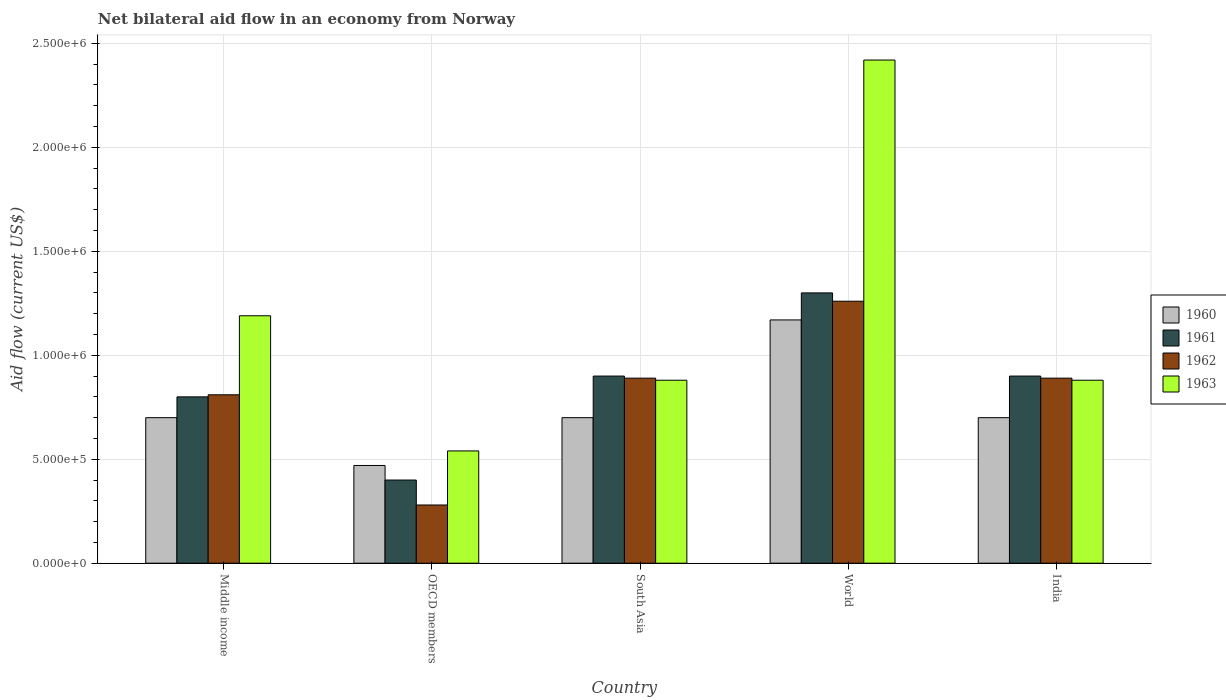How many groups of bars are there?
Offer a very short reply. 5. Are the number of bars per tick equal to the number of legend labels?
Ensure brevity in your answer.  Yes. Are the number of bars on each tick of the X-axis equal?
Your answer should be very brief. Yes. How many bars are there on the 2nd tick from the left?
Give a very brief answer. 4. What is the net bilateral aid flow in 1960 in World?
Make the answer very short. 1.17e+06. Across all countries, what is the maximum net bilateral aid flow in 1961?
Provide a short and direct response. 1.30e+06. What is the total net bilateral aid flow in 1961 in the graph?
Provide a short and direct response. 4.30e+06. What is the difference between the net bilateral aid flow in 1960 in South Asia and that in World?
Give a very brief answer. -4.70e+05. What is the difference between the net bilateral aid flow in 1960 in India and the net bilateral aid flow in 1962 in World?
Keep it short and to the point. -5.60e+05. What is the average net bilateral aid flow in 1963 per country?
Ensure brevity in your answer.  1.18e+06. In how many countries, is the net bilateral aid flow in 1960 greater than 1700000 US$?
Give a very brief answer. 0. What is the ratio of the net bilateral aid flow in 1963 in OECD members to that in South Asia?
Offer a terse response. 0.61. Is the net bilateral aid flow in 1963 in India less than that in OECD members?
Offer a very short reply. No. Is the difference between the net bilateral aid flow in 1960 in Middle income and OECD members greater than the difference between the net bilateral aid flow in 1963 in Middle income and OECD members?
Keep it short and to the point. No. What is the difference between the highest and the second highest net bilateral aid flow in 1961?
Offer a terse response. 4.00e+05. What is the difference between the highest and the lowest net bilateral aid flow in 1963?
Ensure brevity in your answer.  1.88e+06. In how many countries, is the net bilateral aid flow in 1963 greater than the average net bilateral aid flow in 1963 taken over all countries?
Your answer should be very brief. 2. Is it the case that in every country, the sum of the net bilateral aid flow in 1961 and net bilateral aid flow in 1962 is greater than the sum of net bilateral aid flow in 1960 and net bilateral aid flow in 1963?
Make the answer very short. No. Is it the case that in every country, the sum of the net bilateral aid flow in 1960 and net bilateral aid flow in 1961 is greater than the net bilateral aid flow in 1963?
Your response must be concise. Yes. Are the values on the major ticks of Y-axis written in scientific E-notation?
Provide a succinct answer. Yes. Does the graph contain any zero values?
Give a very brief answer. No. How many legend labels are there?
Offer a very short reply. 4. What is the title of the graph?
Offer a terse response. Net bilateral aid flow in an economy from Norway. Does "1974" appear as one of the legend labels in the graph?
Ensure brevity in your answer.  No. What is the Aid flow (current US$) of 1960 in Middle income?
Offer a very short reply. 7.00e+05. What is the Aid flow (current US$) in 1961 in Middle income?
Provide a short and direct response. 8.00e+05. What is the Aid flow (current US$) of 1962 in Middle income?
Make the answer very short. 8.10e+05. What is the Aid flow (current US$) in 1963 in Middle income?
Your answer should be very brief. 1.19e+06. What is the Aid flow (current US$) of 1963 in OECD members?
Ensure brevity in your answer.  5.40e+05. What is the Aid flow (current US$) of 1960 in South Asia?
Give a very brief answer. 7.00e+05. What is the Aid flow (current US$) in 1962 in South Asia?
Provide a short and direct response. 8.90e+05. What is the Aid flow (current US$) of 1963 in South Asia?
Offer a very short reply. 8.80e+05. What is the Aid flow (current US$) of 1960 in World?
Offer a terse response. 1.17e+06. What is the Aid flow (current US$) in 1961 in World?
Provide a short and direct response. 1.30e+06. What is the Aid flow (current US$) of 1962 in World?
Ensure brevity in your answer.  1.26e+06. What is the Aid flow (current US$) of 1963 in World?
Keep it short and to the point. 2.42e+06. What is the Aid flow (current US$) in 1961 in India?
Offer a terse response. 9.00e+05. What is the Aid flow (current US$) of 1962 in India?
Your answer should be very brief. 8.90e+05. What is the Aid flow (current US$) of 1963 in India?
Offer a very short reply. 8.80e+05. Across all countries, what is the maximum Aid flow (current US$) in 1960?
Your response must be concise. 1.17e+06. Across all countries, what is the maximum Aid flow (current US$) of 1961?
Offer a very short reply. 1.30e+06. Across all countries, what is the maximum Aid flow (current US$) in 1962?
Provide a succinct answer. 1.26e+06. Across all countries, what is the maximum Aid flow (current US$) of 1963?
Your response must be concise. 2.42e+06. Across all countries, what is the minimum Aid flow (current US$) in 1963?
Your response must be concise. 5.40e+05. What is the total Aid flow (current US$) in 1960 in the graph?
Your answer should be very brief. 3.74e+06. What is the total Aid flow (current US$) of 1961 in the graph?
Give a very brief answer. 4.30e+06. What is the total Aid flow (current US$) in 1962 in the graph?
Your answer should be very brief. 4.13e+06. What is the total Aid flow (current US$) of 1963 in the graph?
Your answer should be very brief. 5.91e+06. What is the difference between the Aid flow (current US$) in 1960 in Middle income and that in OECD members?
Offer a terse response. 2.30e+05. What is the difference between the Aid flow (current US$) of 1962 in Middle income and that in OECD members?
Ensure brevity in your answer.  5.30e+05. What is the difference between the Aid flow (current US$) of 1963 in Middle income and that in OECD members?
Give a very brief answer. 6.50e+05. What is the difference between the Aid flow (current US$) of 1960 in Middle income and that in South Asia?
Provide a short and direct response. 0. What is the difference between the Aid flow (current US$) in 1962 in Middle income and that in South Asia?
Provide a short and direct response. -8.00e+04. What is the difference between the Aid flow (current US$) in 1960 in Middle income and that in World?
Your response must be concise. -4.70e+05. What is the difference between the Aid flow (current US$) of 1961 in Middle income and that in World?
Provide a short and direct response. -5.00e+05. What is the difference between the Aid flow (current US$) in 1962 in Middle income and that in World?
Provide a short and direct response. -4.50e+05. What is the difference between the Aid flow (current US$) in 1963 in Middle income and that in World?
Your answer should be compact. -1.23e+06. What is the difference between the Aid flow (current US$) in 1960 in OECD members and that in South Asia?
Provide a short and direct response. -2.30e+05. What is the difference between the Aid flow (current US$) of 1961 in OECD members and that in South Asia?
Your answer should be very brief. -5.00e+05. What is the difference between the Aid flow (current US$) in 1962 in OECD members and that in South Asia?
Your answer should be compact. -6.10e+05. What is the difference between the Aid flow (current US$) of 1960 in OECD members and that in World?
Provide a short and direct response. -7.00e+05. What is the difference between the Aid flow (current US$) of 1961 in OECD members and that in World?
Provide a succinct answer. -9.00e+05. What is the difference between the Aid flow (current US$) in 1962 in OECD members and that in World?
Offer a very short reply. -9.80e+05. What is the difference between the Aid flow (current US$) in 1963 in OECD members and that in World?
Make the answer very short. -1.88e+06. What is the difference between the Aid flow (current US$) of 1960 in OECD members and that in India?
Make the answer very short. -2.30e+05. What is the difference between the Aid flow (current US$) in 1961 in OECD members and that in India?
Offer a terse response. -5.00e+05. What is the difference between the Aid flow (current US$) in 1962 in OECD members and that in India?
Keep it short and to the point. -6.10e+05. What is the difference between the Aid flow (current US$) of 1963 in OECD members and that in India?
Keep it short and to the point. -3.40e+05. What is the difference between the Aid flow (current US$) in 1960 in South Asia and that in World?
Make the answer very short. -4.70e+05. What is the difference between the Aid flow (current US$) of 1961 in South Asia and that in World?
Provide a short and direct response. -4.00e+05. What is the difference between the Aid flow (current US$) in 1962 in South Asia and that in World?
Make the answer very short. -3.70e+05. What is the difference between the Aid flow (current US$) of 1963 in South Asia and that in World?
Provide a succinct answer. -1.54e+06. What is the difference between the Aid flow (current US$) in 1960 in South Asia and that in India?
Provide a short and direct response. 0. What is the difference between the Aid flow (current US$) of 1960 in World and that in India?
Make the answer very short. 4.70e+05. What is the difference between the Aid flow (current US$) of 1963 in World and that in India?
Offer a terse response. 1.54e+06. What is the difference between the Aid flow (current US$) of 1960 in Middle income and the Aid flow (current US$) of 1962 in OECD members?
Your answer should be compact. 4.20e+05. What is the difference between the Aid flow (current US$) in 1960 in Middle income and the Aid flow (current US$) in 1963 in OECD members?
Offer a very short reply. 1.60e+05. What is the difference between the Aid flow (current US$) in 1961 in Middle income and the Aid flow (current US$) in 1962 in OECD members?
Ensure brevity in your answer.  5.20e+05. What is the difference between the Aid flow (current US$) of 1961 in Middle income and the Aid flow (current US$) of 1963 in OECD members?
Offer a very short reply. 2.60e+05. What is the difference between the Aid flow (current US$) of 1962 in Middle income and the Aid flow (current US$) of 1963 in OECD members?
Your answer should be very brief. 2.70e+05. What is the difference between the Aid flow (current US$) of 1960 in Middle income and the Aid flow (current US$) of 1961 in South Asia?
Offer a very short reply. -2.00e+05. What is the difference between the Aid flow (current US$) in 1960 in Middle income and the Aid flow (current US$) in 1962 in South Asia?
Your answer should be very brief. -1.90e+05. What is the difference between the Aid flow (current US$) of 1961 in Middle income and the Aid flow (current US$) of 1962 in South Asia?
Your answer should be compact. -9.00e+04. What is the difference between the Aid flow (current US$) in 1961 in Middle income and the Aid flow (current US$) in 1963 in South Asia?
Your answer should be compact. -8.00e+04. What is the difference between the Aid flow (current US$) in 1960 in Middle income and the Aid flow (current US$) in 1961 in World?
Offer a terse response. -6.00e+05. What is the difference between the Aid flow (current US$) in 1960 in Middle income and the Aid flow (current US$) in 1962 in World?
Provide a short and direct response. -5.60e+05. What is the difference between the Aid flow (current US$) in 1960 in Middle income and the Aid flow (current US$) in 1963 in World?
Offer a very short reply. -1.72e+06. What is the difference between the Aid flow (current US$) in 1961 in Middle income and the Aid flow (current US$) in 1962 in World?
Make the answer very short. -4.60e+05. What is the difference between the Aid flow (current US$) of 1961 in Middle income and the Aid flow (current US$) of 1963 in World?
Keep it short and to the point. -1.62e+06. What is the difference between the Aid flow (current US$) in 1962 in Middle income and the Aid flow (current US$) in 1963 in World?
Your answer should be compact. -1.61e+06. What is the difference between the Aid flow (current US$) of 1960 in Middle income and the Aid flow (current US$) of 1961 in India?
Your response must be concise. -2.00e+05. What is the difference between the Aid flow (current US$) of 1960 in Middle income and the Aid flow (current US$) of 1963 in India?
Make the answer very short. -1.80e+05. What is the difference between the Aid flow (current US$) of 1961 in Middle income and the Aid flow (current US$) of 1962 in India?
Offer a very short reply. -9.00e+04. What is the difference between the Aid flow (current US$) in 1962 in Middle income and the Aid flow (current US$) in 1963 in India?
Offer a very short reply. -7.00e+04. What is the difference between the Aid flow (current US$) in 1960 in OECD members and the Aid flow (current US$) in 1961 in South Asia?
Keep it short and to the point. -4.30e+05. What is the difference between the Aid flow (current US$) in 1960 in OECD members and the Aid flow (current US$) in 1962 in South Asia?
Your answer should be compact. -4.20e+05. What is the difference between the Aid flow (current US$) of 1960 in OECD members and the Aid flow (current US$) of 1963 in South Asia?
Ensure brevity in your answer.  -4.10e+05. What is the difference between the Aid flow (current US$) in 1961 in OECD members and the Aid flow (current US$) in 1962 in South Asia?
Provide a short and direct response. -4.90e+05. What is the difference between the Aid flow (current US$) in 1961 in OECD members and the Aid flow (current US$) in 1963 in South Asia?
Keep it short and to the point. -4.80e+05. What is the difference between the Aid flow (current US$) in 1962 in OECD members and the Aid flow (current US$) in 1963 in South Asia?
Provide a succinct answer. -6.00e+05. What is the difference between the Aid flow (current US$) of 1960 in OECD members and the Aid flow (current US$) of 1961 in World?
Give a very brief answer. -8.30e+05. What is the difference between the Aid flow (current US$) in 1960 in OECD members and the Aid flow (current US$) in 1962 in World?
Make the answer very short. -7.90e+05. What is the difference between the Aid flow (current US$) of 1960 in OECD members and the Aid flow (current US$) of 1963 in World?
Make the answer very short. -1.95e+06. What is the difference between the Aid flow (current US$) in 1961 in OECD members and the Aid flow (current US$) in 1962 in World?
Give a very brief answer. -8.60e+05. What is the difference between the Aid flow (current US$) of 1961 in OECD members and the Aid flow (current US$) of 1963 in World?
Provide a short and direct response. -2.02e+06. What is the difference between the Aid flow (current US$) in 1962 in OECD members and the Aid flow (current US$) in 1963 in World?
Ensure brevity in your answer.  -2.14e+06. What is the difference between the Aid flow (current US$) of 1960 in OECD members and the Aid flow (current US$) of 1961 in India?
Keep it short and to the point. -4.30e+05. What is the difference between the Aid flow (current US$) of 1960 in OECD members and the Aid flow (current US$) of 1962 in India?
Keep it short and to the point. -4.20e+05. What is the difference between the Aid flow (current US$) in 1960 in OECD members and the Aid flow (current US$) in 1963 in India?
Your answer should be compact. -4.10e+05. What is the difference between the Aid flow (current US$) of 1961 in OECD members and the Aid flow (current US$) of 1962 in India?
Your answer should be very brief. -4.90e+05. What is the difference between the Aid flow (current US$) in 1961 in OECD members and the Aid flow (current US$) in 1963 in India?
Provide a succinct answer. -4.80e+05. What is the difference between the Aid flow (current US$) of 1962 in OECD members and the Aid flow (current US$) of 1963 in India?
Make the answer very short. -6.00e+05. What is the difference between the Aid flow (current US$) in 1960 in South Asia and the Aid flow (current US$) in 1961 in World?
Keep it short and to the point. -6.00e+05. What is the difference between the Aid flow (current US$) of 1960 in South Asia and the Aid flow (current US$) of 1962 in World?
Your response must be concise. -5.60e+05. What is the difference between the Aid flow (current US$) of 1960 in South Asia and the Aid flow (current US$) of 1963 in World?
Offer a terse response. -1.72e+06. What is the difference between the Aid flow (current US$) of 1961 in South Asia and the Aid flow (current US$) of 1962 in World?
Your answer should be compact. -3.60e+05. What is the difference between the Aid flow (current US$) in 1961 in South Asia and the Aid flow (current US$) in 1963 in World?
Offer a very short reply. -1.52e+06. What is the difference between the Aid flow (current US$) of 1962 in South Asia and the Aid flow (current US$) of 1963 in World?
Keep it short and to the point. -1.53e+06. What is the difference between the Aid flow (current US$) in 1960 in South Asia and the Aid flow (current US$) in 1961 in India?
Keep it short and to the point. -2.00e+05. What is the difference between the Aid flow (current US$) of 1960 in South Asia and the Aid flow (current US$) of 1962 in India?
Keep it short and to the point. -1.90e+05. What is the difference between the Aid flow (current US$) of 1960 in South Asia and the Aid flow (current US$) of 1963 in India?
Make the answer very short. -1.80e+05. What is the difference between the Aid flow (current US$) of 1960 in World and the Aid flow (current US$) of 1963 in India?
Your answer should be very brief. 2.90e+05. What is the difference between the Aid flow (current US$) of 1961 in World and the Aid flow (current US$) of 1962 in India?
Keep it short and to the point. 4.10e+05. What is the difference between the Aid flow (current US$) in 1962 in World and the Aid flow (current US$) in 1963 in India?
Keep it short and to the point. 3.80e+05. What is the average Aid flow (current US$) in 1960 per country?
Offer a terse response. 7.48e+05. What is the average Aid flow (current US$) of 1961 per country?
Offer a very short reply. 8.60e+05. What is the average Aid flow (current US$) in 1962 per country?
Ensure brevity in your answer.  8.26e+05. What is the average Aid flow (current US$) in 1963 per country?
Give a very brief answer. 1.18e+06. What is the difference between the Aid flow (current US$) of 1960 and Aid flow (current US$) of 1961 in Middle income?
Ensure brevity in your answer.  -1.00e+05. What is the difference between the Aid flow (current US$) of 1960 and Aid flow (current US$) of 1963 in Middle income?
Give a very brief answer. -4.90e+05. What is the difference between the Aid flow (current US$) of 1961 and Aid flow (current US$) of 1963 in Middle income?
Offer a terse response. -3.90e+05. What is the difference between the Aid flow (current US$) of 1962 and Aid flow (current US$) of 1963 in Middle income?
Your answer should be compact. -3.80e+05. What is the difference between the Aid flow (current US$) in 1960 and Aid flow (current US$) in 1962 in OECD members?
Provide a succinct answer. 1.90e+05. What is the difference between the Aid flow (current US$) of 1960 and Aid flow (current US$) of 1963 in OECD members?
Ensure brevity in your answer.  -7.00e+04. What is the difference between the Aid flow (current US$) in 1961 and Aid flow (current US$) in 1962 in OECD members?
Give a very brief answer. 1.20e+05. What is the difference between the Aid flow (current US$) of 1961 and Aid flow (current US$) of 1963 in OECD members?
Make the answer very short. -1.40e+05. What is the difference between the Aid flow (current US$) of 1960 and Aid flow (current US$) of 1961 in South Asia?
Make the answer very short. -2.00e+05. What is the difference between the Aid flow (current US$) of 1960 and Aid flow (current US$) of 1962 in South Asia?
Keep it short and to the point. -1.90e+05. What is the difference between the Aid flow (current US$) in 1960 and Aid flow (current US$) in 1963 in South Asia?
Your answer should be very brief. -1.80e+05. What is the difference between the Aid flow (current US$) in 1961 and Aid flow (current US$) in 1963 in South Asia?
Your answer should be very brief. 2.00e+04. What is the difference between the Aid flow (current US$) in 1962 and Aid flow (current US$) in 1963 in South Asia?
Give a very brief answer. 10000. What is the difference between the Aid flow (current US$) of 1960 and Aid flow (current US$) of 1963 in World?
Keep it short and to the point. -1.25e+06. What is the difference between the Aid flow (current US$) of 1961 and Aid flow (current US$) of 1962 in World?
Offer a very short reply. 4.00e+04. What is the difference between the Aid flow (current US$) in 1961 and Aid flow (current US$) in 1963 in World?
Make the answer very short. -1.12e+06. What is the difference between the Aid flow (current US$) in 1962 and Aid flow (current US$) in 1963 in World?
Offer a very short reply. -1.16e+06. What is the difference between the Aid flow (current US$) of 1960 and Aid flow (current US$) of 1961 in India?
Keep it short and to the point. -2.00e+05. What is the difference between the Aid flow (current US$) of 1960 and Aid flow (current US$) of 1962 in India?
Give a very brief answer. -1.90e+05. What is the difference between the Aid flow (current US$) of 1960 and Aid flow (current US$) of 1963 in India?
Give a very brief answer. -1.80e+05. What is the difference between the Aid flow (current US$) in 1961 and Aid flow (current US$) in 1962 in India?
Your answer should be very brief. 10000. What is the difference between the Aid flow (current US$) in 1961 and Aid flow (current US$) in 1963 in India?
Your response must be concise. 2.00e+04. What is the difference between the Aid flow (current US$) in 1962 and Aid flow (current US$) in 1963 in India?
Ensure brevity in your answer.  10000. What is the ratio of the Aid flow (current US$) of 1960 in Middle income to that in OECD members?
Make the answer very short. 1.49. What is the ratio of the Aid flow (current US$) in 1961 in Middle income to that in OECD members?
Ensure brevity in your answer.  2. What is the ratio of the Aid flow (current US$) of 1962 in Middle income to that in OECD members?
Offer a terse response. 2.89. What is the ratio of the Aid flow (current US$) in 1963 in Middle income to that in OECD members?
Provide a succinct answer. 2.2. What is the ratio of the Aid flow (current US$) in 1960 in Middle income to that in South Asia?
Keep it short and to the point. 1. What is the ratio of the Aid flow (current US$) of 1962 in Middle income to that in South Asia?
Offer a terse response. 0.91. What is the ratio of the Aid flow (current US$) in 1963 in Middle income to that in South Asia?
Ensure brevity in your answer.  1.35. What is the ratio of the Aid flow (current US$) in 1960 in Middle income to that in World?
Your answer should be very brief. 0.6. What is the ratio of the Aid flow (current US$) in 1961 in Middle income to that in World?
Your answer should be very brief. 0.62. What is the ratio of the Aid flow (current US$) in 1962 in Middle income to that in World?
Provide a short and direct response. 0.64. What is the ratio of the Aid flow (current US$) of 1963 in Middle income to that in World?
Your answer should be very brief. 0.49. What is the ratio of the Aid flow (current US$) of 1961 in Middle income to that in India?
Make the answer very short. 0.89. What is the ratio of the Aid flow (current US$) of 1962 in Middle income to that in India?
Your answer should be very brief. 0.91. What is the ratio of the Aid flow (current US$) in 1963 in Middle income to that in India?
Your answer should be compact. 1.35. What is the ratio of the Aid flow (current US$) of 1960 in OECD members to that in South Asia?
Ensure brevity in your answer.  0.67. What is the ratio of the Aid flow (current US$) of 1961 in OECD members to that in South Asia?
Your answer should be very brief. 0.44. What is the ratio of the Aid flow (current US$) of 1962 in OECD members to that in South Asia?
Your answer should be compact. 0.31. What is the ratio of the Aid flow (current US$) of 1963 in OECD members to that in South Asia?
Keep it short and to the point. 0.61. What is the ratio of the Aid flow (current US$) in 1960 in OECD members to that in World?
Provide a short and direct response. 0.4. What is the ratio of the Aid flow (current US$) in 1961 in OECD members to that in World?
Ensure brevity in your answer.  0.31. What is the ratio of the Aid flow (current US$) in 1962 in OECD members to that in World?
Your response must be concise. 0.22. What is the ratio of the Aid flow (current US$) of 1963 in OECD members to that in World?
Offer a very short reply. 0.22. What is the ratio of the Aid flow (current US$) of 1960 in OECD members to that in India?
Make the answer very short. 0.67. What is the ratio of the Aid flow (current US$) in 1961 in OECD members to that in India?
Your answer should be very brief. 0.44. What is the ratio of the Aid flow (current US$) of 1962 in OECD members to that in India?
Your response must be concise. 0.31. What is the ratio of the Aid flow (current US$) in 1963 in OECD members to that in India?
Your answer should be compact. 0.61. What is the ratio of the Aid flow (current US$) of 1960 in South Asia to that in World?
Your answer should be very brief. 0.6. What is the ratio of the Aid flow (current US$) in 1961 in South Asia to that in World?
Provide a succinct answer. 0.69. What is the ratio of the Aid flow (current US$) in 1962 in South Asia to that in World?
Keep it short and to the point. 0.71. What is the ratio of the Aid flow (current US$) of 1963 in South Asia to that in World?
Make the answer very short. 0.36. What is the ratio of the Aid flow (current US$) in 1960 in South Asia to that in India?
Your answer should be very brief. 1. What is the ratio of the Aid flow (current US$) of 1963 in South Asia to that in India?
Your answer should be very brief. 1. What is the ratio of the Aid flow (current US$) of 1960 in World to that in India?
Offer a very short reply. 1.67. What is the ratio of the Aid flow (current US$) of 1961 in World to that in India?
Ensure brevity in your answer.  1.44. What is the ratio of the Aid flow (current US$) of 1962 in World to that in India?
Make the answer very short. 1.42. What is the ratio of the Aid flow (current US$) in 1963 in World to that in India?
Make the answer very short. 2.75. What is the difference between the highest and the second highest Aid flow (current US$) of 1961?
Offer a terse response. 4.00e+05. What is the difference between the highest and the second highest Aid flow (current US$) in 1963?
Provide a short and direct response. 1.23e+06. What is the difference between the highest and the lowest Aid flow (current US$) of 1962?
Your response must be concise. 9.80e+05. What is the difference between the highest and the lowest Aid flow (current US$) of 1963?
Offer a very short reply. 1.88e+06. 